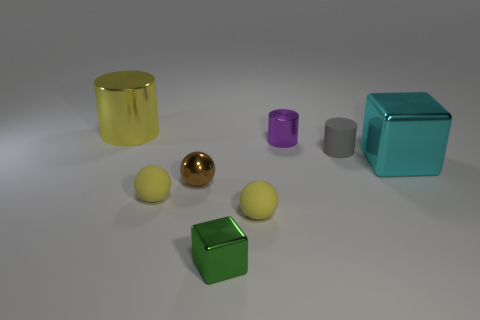There is a small matte sphere that is on the right side of the tiny metal sphere; is it the same color as the big shiny cylinder?
Offer a very short reply. Yes. There is a cube that is to the right of the tiny purple metal cylinder; what material is it?
Your answer should be compact. Metal. There is a small thing that is in front of the small purple metal cylinder and behind the small brown object; what material is it made of?
Offer a terse response. Rubber. There is a block to the left of the cyan metallic block; is it the same size as the big yellow thing?
Give a very brief answer. No. There is a tiny purple metal thing; what shape is it?
Your response must be concise. Cylinder. How many tiny gray matte things have the same shape as the tiny green thing?
Make the answer very short. 0. What number of objects are left of the purple shiny object and in front of the large yellow thing?
Your answer should be very brief. 4. What is the color of the big cylinder?
Keep it short and to the point. Yellow. Are there any cubes made of the same material as the small purple cylinder?
Make the answer very short. Yes. There is a thing to the right of the matte thing that is behind the big cyan metallic block; are there any small yellow matte spheres that are behind it?
Offer a very short reply. No. 